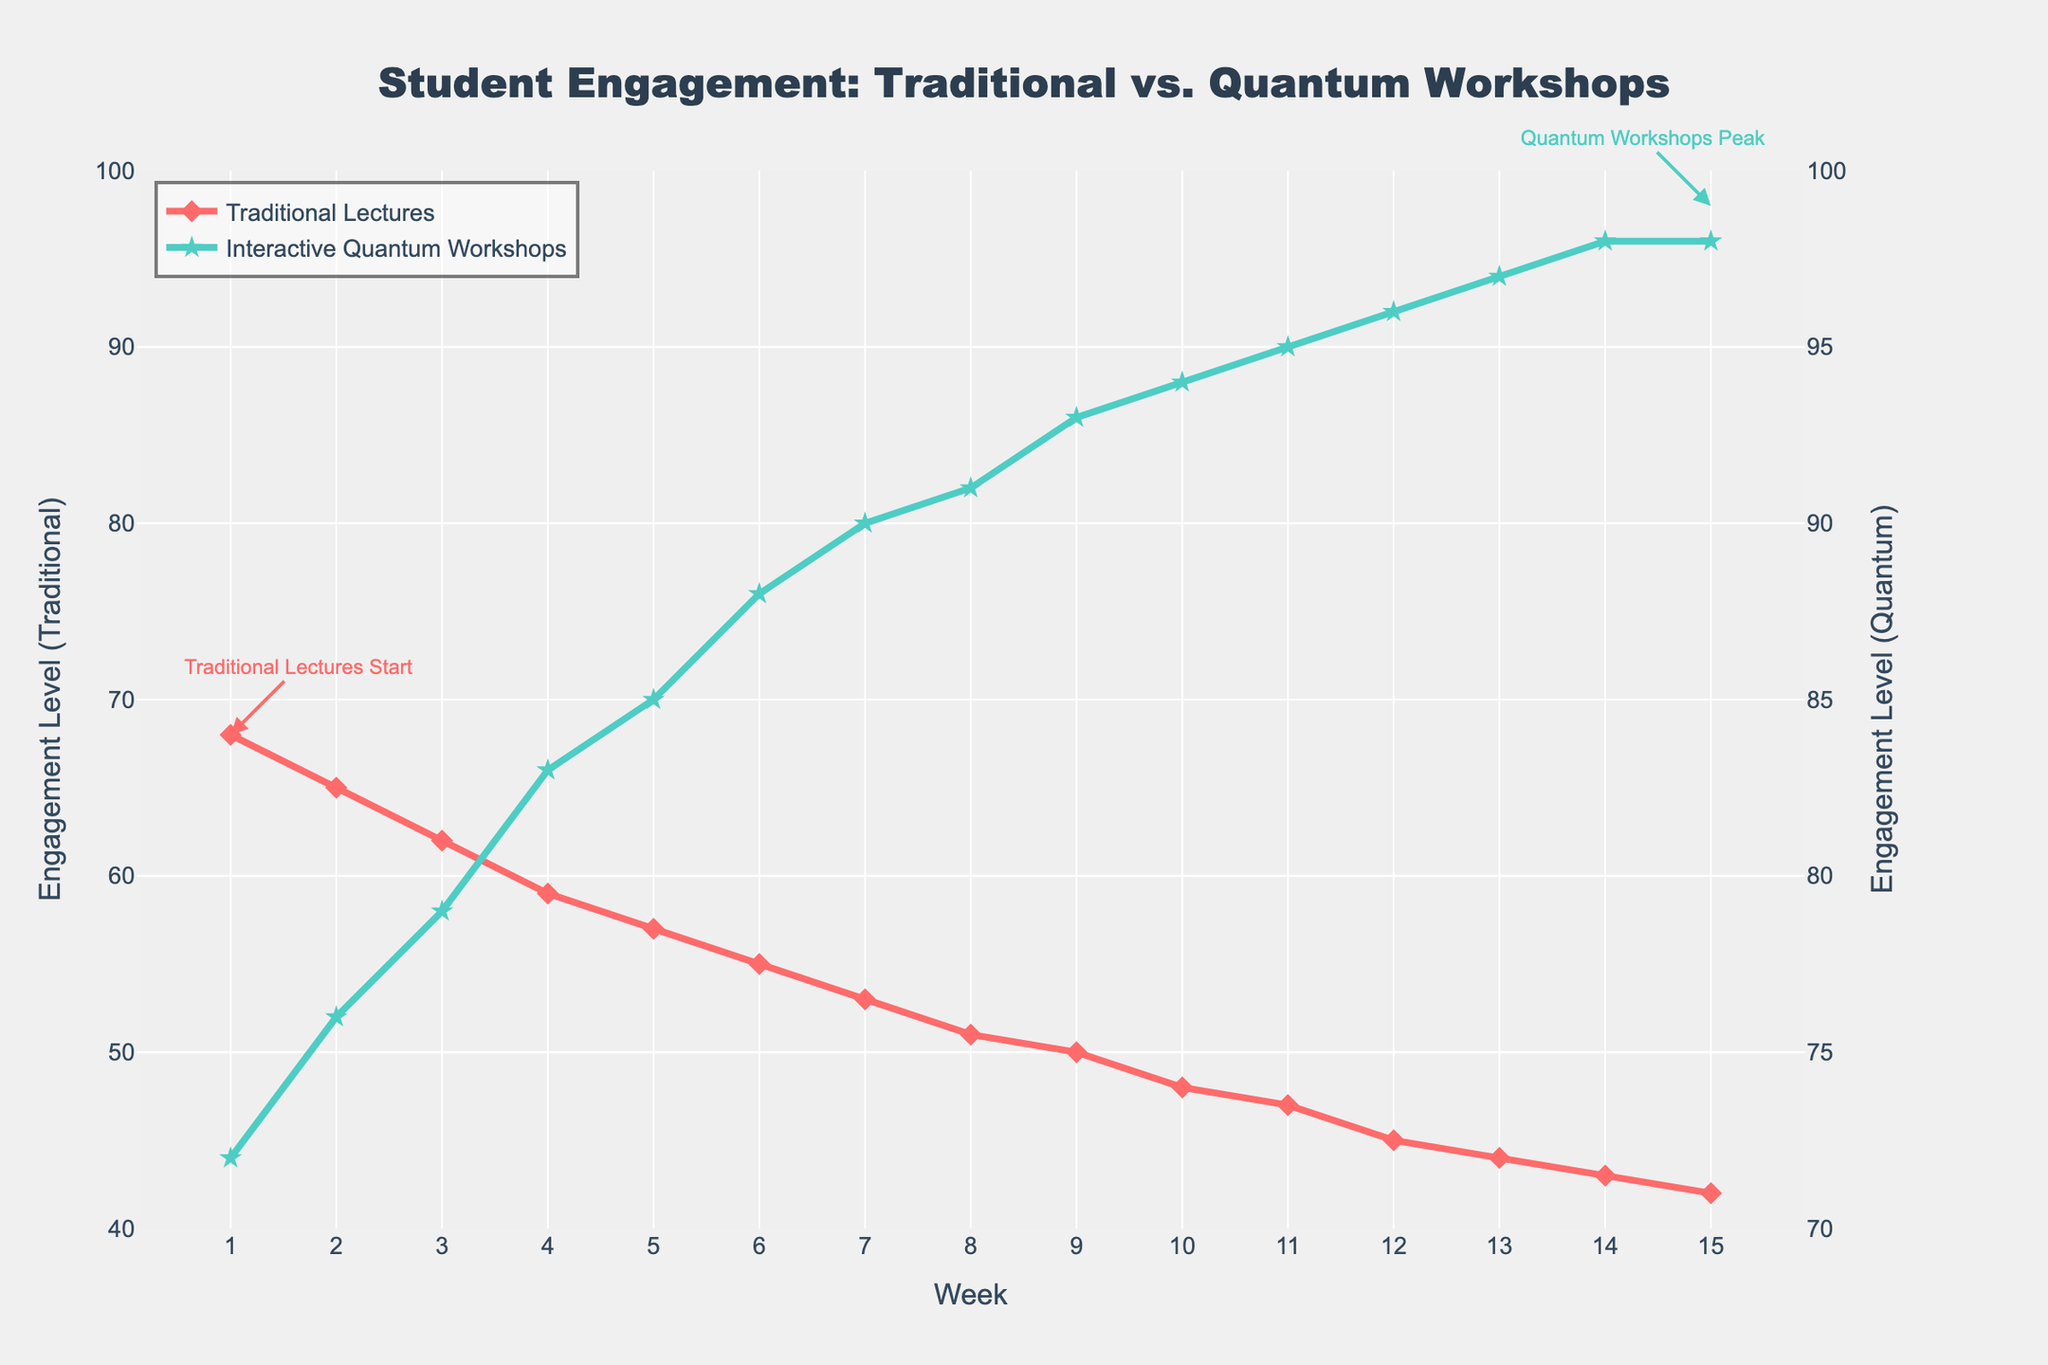What's the trend in engagement levels for traditional lectures over the semester? Starting from week 1, traditional lecture engagement levels decline steadily from 68 to 42 by week 15.
Answer: Decline from 68 to 42 How does the engagement level in week 5 for interactive quantum workshops compare to traditional lectures? In week 5, the engagement level for interactive quantum workshops is 85, while for traditional lectures, it is 57.
Answer: Interactive: 85, Traditional: 57 What is the average engagement level of interactive quantum workshops in the first 5 weeks? The engagement levels for the first 5 weeks are 72, 76, 79, 83, and 85. The sum is 395, so the average is 395 / 5 = 79.
Answer: 79 What is the highest engagement level achieved in interactive quantum workshops? The highest engagement level for interactive quantum workshops reaches 98 in both weeks 14 and 15.
Answer: 98 Compare the engagement levels between both method peaks, which one, and by how much? The highest engagement level for traditional lectures is 68 in week 1, and for interactive quantum workshops, it is 98. The difference is 98 - 68 = 30.
Answer: Quantum: 98, Traditional: 68, Difference: 30 Which week shows the largest gap in engagement levels between the two teaching methods? In week 15, the engagement level for traditional lectures is 42, and for interactive quantum workshops, it is 98. The gap is 98 - 42 = 56.
Answer: Week 15, Gap: 56 Identify the color used to represent the data for interactive quantum workshops. The line representing interactive quantum workshops is green.
Answer: Green From visual inspection, how does the marker style for traditional lectures differ from interactive quantum workshops? Traditional lectures are shown with diamond markers, while interactive quantum workshops are represented with star markers.
Answer: Diamonds vs. Stars 